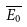<formula> <loc_0><loc_0><loc_500><loc_500>\overline { E _ { 0 } }</formula> 